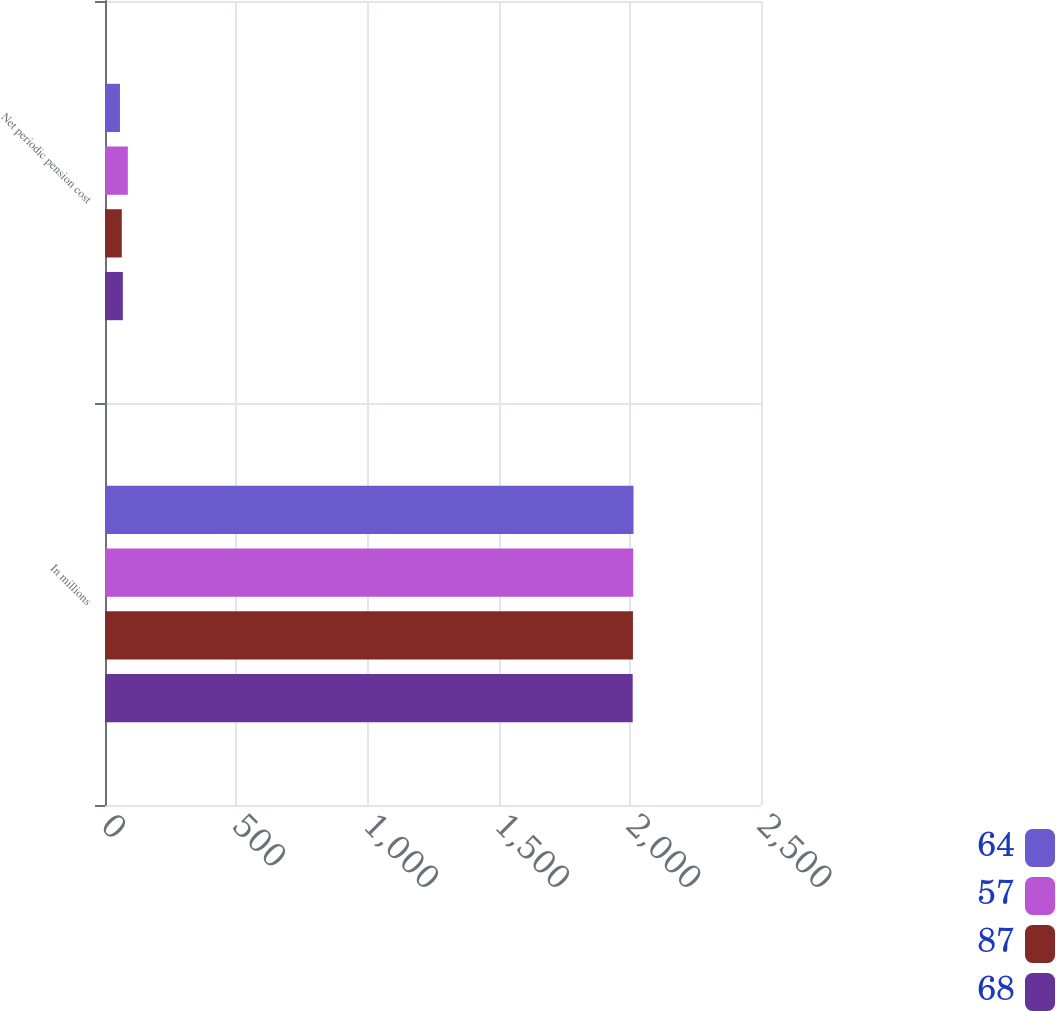Convert chart to OTSL. <chart><loc_0><loc_0><loc_500><loc_500><stacked_bar_chart><ecel><fcel>In millions<fcel>Net periodic pension cost<nl><fcel>64<fcel>2014<fcel>57<nl><fcel>57<fcel>2013<fcel>87<nl><fcel>87<fcel>2012<fcel>64<nl><fcel>68<fcel>2011<fcel>68<nl></chart> 